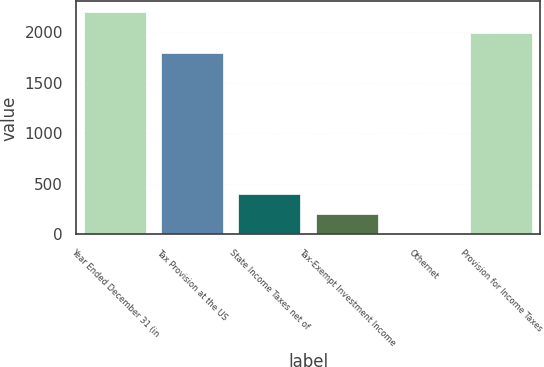Convert chart. <chart><loc_0><loc_0><loc_500><loc_500><bar_chart><fcel>Year Ended December 31 (in<fcel>Tax Provision at the US<fcel>State Income Taxes net of<fcel>Tax-Exempt Investment Income<fcel>Othernet<fcel>Provision for Income Taxes<nl><fcel>2196.8<fcel>1796<fcel>401.8<fcel>201.4<fcel>1<fcel>1996.4<nl></chart> 